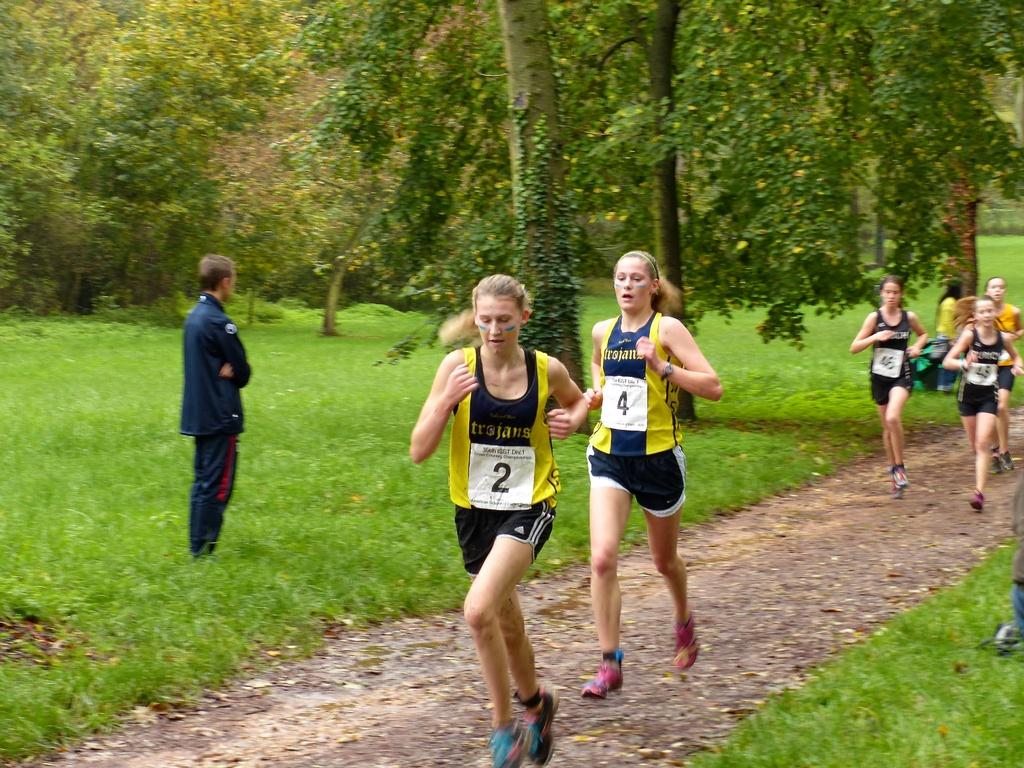What are the people in the image doing? The people in the image are running on a path. Can you describe the man's position in the image? The man is standing on the grass in the image. What can be seen in the background of the image? Trees are visible in the background of the image. What type of game is the man playing with his sister in the image? There is no mention of a game or a sister in the image; it only shows people running on a path and a man standing on the grass. 